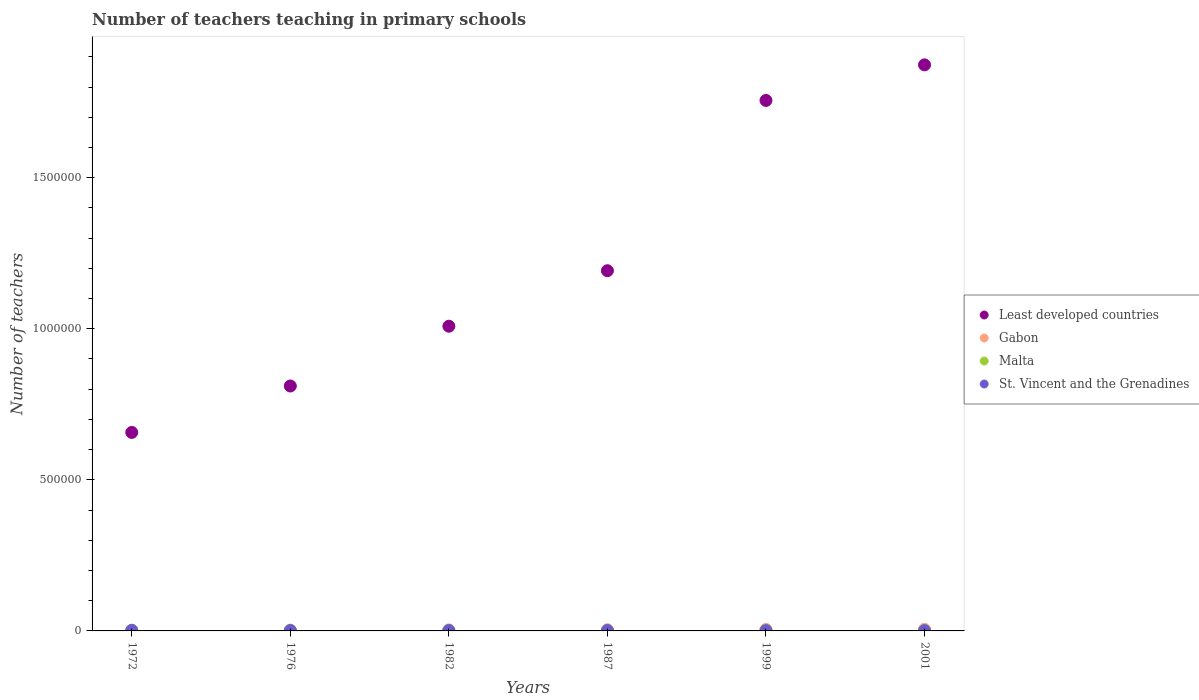How many different coloured dotlines are there?
Provide a short and direct response. 4. Is the number of dotlines equal to the number of legend labels?
Your answer should be very brief. Yes. What is the number of teachers teaching in primary schools in Least developed countries in 2001?
Ensure brevity in your answer.  1.87e+06. Across all years, what is the maximum number of teachers teaching in primary schools in Gabon?
Offer a terse response. 5399. Across all years, what is the minimum number of teachers teaching in primary schools in St. Vincent and the Grenadines?
Provide a succinct answer. 1004. In which year was the number of teachers teaching in primary schools in Malta maximum?
Offer a terse response. 1999. What is the total number of teachers teaching in primary schools in Gabon in the graph?
Give a very brief answer. 2.32e+04. What is the difference between the number of teachers teaching in primary schools in Gabon in 1976 and that in 1999?
Give a very brief answer. -2443. What is the difference between the number of teachers teaching in primary schools in St. Vincent and the Grenadines in 1999 and the number of teachers teaching in primary schools in Least developed countries in 2001?
Make the answer very short. -1.87e+06. What is the average number of teachers teaching in primary schools in Least developed countries per year?
Ensure brevity in your answer.  1.22e+06. In the year 1982, what is the difference between the number of teachers teaching in primary schools in Least developed countries and number of teachers teaching in primary schools in Gabon?
Provide a short and direct response. 1.00e+06. In how many years, is the number of teachers teaching in primary schools in Least developed countries greater than 500000?
Your answer should be compact. 6. What is the ratio of the number of teachers teaching in primary schools in Gabon in 1982 to that in 1999?
Your response must be concise. 0.69. What is the difference between the highest and the second highest number of teachers teaching in primary schools in St. Vincent and the Grenadines?
Give a very brief answer. 507. What is the difference between the highest and the lowest number of teachers teaching in primary schools in Least developed countries?
Keep it short and to the point. 1.22e+06. Is it the case that in every year, the sum of the number of teachers teaching in primary schools in Gabon and number of teachers teaching in primary schools in Malta  is greater than the number of teachers teaching in primary schools in Least developed countries?
Ensure brevity in your answer.  No. Is the number of teachers teaching in primary schools in St. Vincent and the Grenadines strictly greater than the number of teachers teaching in primary schools in Malta over the years?
Your response must be concise. No. What is the difference between two consecutive major ticks on the Y-axis?
Your response must be concise. 5.00e+05. Are the values on the major ticks of Y-axis written in scientific E-notation?
Give a very brief answer. No. Does the graph contain grids?
Ensure brevity in your answer.  No. Where does the legend appear in the graph?
Ensure brevity in your answer.  Center right. How are the legend labels stacked?
Your answer should be compact. Vertical. What is the title of the graph?
Offer a terse response. Number of teachers teaching in primary schools. What is the label or title of the Y-axis?
Keep it short and to the point. Number of teachers. What is the Number of teachers of Least developed countries in 1972?
Ensure brevity in your answer.  6.57e+05. What is the Number of teachers of Gabon in 1972?
Ensure brevity in your answer.  2414. What is the Number of teachers in Malta in 1972?
Provide a short and direct response. 1492. What is the Number of teachers in St. Vincent and the Grenadines in 1972?
Ensure brevity in your answer.  1765. What is the Number of teachers of Least developed countries in 1976?
Provide a succinct answer. 8.11e+05. What is the Number of teachers in Gabon in 1976?
Keep it short and to the point. 2664. What is the Number of teachers in Malta in 1976?
Your answer should be very brief. 1421. What is the Number of teachers of St. Vincent and the Grenadines in 1976?
Your answer should be very brief. 1210. What is the Number of teachers in Least developed countries in 1982?
Offer a terse response. 1.01e+06. What is the Number of teachers in Gabon in 1982?
Give a very brief answer. 3526. What is the Number of teachers of Malta in 1982?
Make the answer very short. 1588. What is the Number of teachers of St. Vincent and the Grenadines in 1982?
Provide a short and direct response. 1184. What is the Number of teachers of Least developed countries in 1987?
Ensure brevity in your answer.  1.19e+06. What is the Number of teachers in Gabon in 1987?
Offer a very short reply. 4083. What is the Number of teachers of Malta in 1987?
Make the answer very short. 1521. What is the Number of teachers of St. Vincent and the Grenadines in 1987?
Your answer should be compact. 1258. What is the Number of teachers in Least developed countries in 1999?
Offer a terse response. 1.76e+06. What is the Number of teachers of Gabon in 1999?
Give a very brief answer. 5107. What is the Number of teachers of Malta in 1999?
Provide a succinct answer. 1779. What is the Number of teachers of St. Vincent and the Grenadines in 1999?
Your answer should be compact. 1004. What is the Number of teachers of Least developed countries in 2001?
Your response must be concise. 1.87e+06. What is the Number of teachers in Gabon in 2001?
Ensure brevity in your answer.  5399. What is the Number of teachers of Malta in 2001?
Give a very brief answer. 1765. What is the Number of teachers of St. Vincent and the Grenadines in 2001?
Provide a succinct answer. 1004. Across all years, what is the maximum Number of teachers in Least developed countries?
Your answer should be compact. 1.87e+06. Across all years, what is the maximum Number of teachers in Gabon?
Provide a short and direct response. 5399. Across all years, what is the maximum Number of teachers in Malta?
Your response must be concise. 1779. Across all years, what is the maximum Number of teachers in St. Vincent and the Grenadines?
Provide a short and direct response. 1765. Across all years, what is the minimum Number of teachers of Least developed countries?
Keep it short and to the point. 6.57e+05. Across all years, what is the minimum Number of teachers of Gabon?
Offer a terse response. 2414. Across all years, what is the minimum Number of teachers in Malta?
Your answer should be compact. 1421. Across all years, what is the minimum Number of teachers in St. Vincent and the Grenadines?
Offer a very short reply. 1004. What is the total Number of teachers of Least developed countries in the graph?
Provide a short and direct response. 7.30e+06. What is the total Number of teachers of Gabon in the graph?
Your answer should be compact. 2.32e+04. What is the total Number of teachers of Malta in the graph?
Keep it short and to the point. 9566. What is the total Number of teachers of St. Vincent and the Grenadines in the graph?
Give a very brief answer. 7425. What is the difference between the Number of teachers of Least developed countries in 1972 and that in 1976?
Keep it short and to the point. -1.54e+05. What is the difference between the Number of teachers in Gabon in 1972 and that in 1976?
Provide a succinct answer. -250. What is the difference between the Number of teachers in Malta in 1972 and that in 1976?
Keep it short and to the point. 71. What is the difference between the Number of teachers of St. Vincent and the Grenadines in 1972 and that in 1976?
Offer a very short reply. 555. What is the difference between the Number of teachers in Least developed countries in 1972 and that in 1982?
Make the answer very short. -3.51e+05. What is the difference between the Number of teachers of Gabon in 1972 and that in 1982?
Your response must be concise. -1112. What is the difference between the Number of teachers in Malta in 1972 and that in 1982?
Ensure brevity in your answer.  -96. What is the difference between the Number of teachers of St. Vincent and the Grenadines in 1972 and that in 1982?
Your answer should be compact. 581. What is the difference between the Number of teachers in Least developed countries in 1972 and that in 1987?
Your answer should be very brief. -5.35e+05. What is the difference between the Number of teachers of Gabon in 1972 and that in 1987?
Make the answer very short. -1669. What is the difference between the Number of teachers in Malta in 1972 and that in 1987?
Provide a short and direct response. -29. What is the difference between the Number of teachers in St. Vincent and the Grenadines in 1972 and that in 1987?
Your answer should be compact. 507. What is the difference between the Number of teachers in Least developed countries in 1972 and that in 1999?
Your answer should be compact. -1.10e+06. What is the difference between the Number of teachers in Gabon in 1972 and that in 1999?
Keep it short and to the point. -2693. What is the difference between the Number of teachers in Malta in 1972 and that in 1999?
Your answer should be compact. -287. What is the difference between the Number of teachers of St. Vincent and the Grenadines in 1972 and that in 1999?
Your answer should be compact. 761. What is the difference between the Number of teachers in Least developed countries in 1972 and that in 2001?
Provide a short and direct response. -1.22e+06. What is the difference between the Number of teachers of Gabon in 1972 and that in 2001?
Ensure brevity in your answer.  -2985. What is the difference between the Number of teachers in Malta in 1972 and that in 2001?
Provide a succinct answer. -273. What is the difference between the Number of teachers in St. Vincent and the Grenadines in 1972 and that in 2001?
Give a very brief answer. 761. What is the difference between the Number of teachers of Least developed countries in 1976 and that in 1982?
Ensure brevity in your answer.  -1.98e+05. What is the difference between the Number of teachers in Gabon in 1976 and that in 1982?
Give a very brief answer. -862. What is the difference between the Number of teachers in Malta in 1976 and that in 1982?
Your answer should be compact. -167. What is the difference between the Number of teachers in St. Vincent and the Grenadines in 1976 and that in 1982?
Ensure brevity in your answer.  26. What is the difference between the Number of teachers of Least developed countries in 1976 and that in 1987?
Keep it short and to the point. -3.81e+05. What is the difference between the Number of teachers in Gabon in 1976 and that in 1987?
Your answer should be very brief. -1419. What is the difference between the Number of teachers in Malta in 1976 and that in 1987?
Ensure brevity in your answer.  -100. What is the difference between the Number of teachers in St. Vincent and the Grenadines in 1976 and that in 1987?
Give a very brief answer. -48. What is the difference between the Number of teachers in Least developed countries in 1976 and that in 1999?
Your answer should be compact. -9.45e+05. What is the difference between the Number of teachers of Gabon in 1976 and that in 1999?
Your answer should be compact. -2443. What is the difference between the Number of teachers in Malta in 1976 and that in 1999?
Ensure brevity in your answer.  -358. What is the difference between the Number of teachers in St. Vincent and the Grenadines in 1976 and that in 1999?
Provide a short and direct response. 206. What is the difference between the Number of teachers of Least developed countries in 1976 and that in 2001?
Make the answer very short. -1.06e+06. What is the difference between the Number of teachers of Gabon in 1976 and that in 2001?
Provide a short and direct response. -2735. What is the difference between the Number of teachers of Malta in 1976 and that in 2001?
Your answer should be compact. -344. What is the difference between the Number of teachers of St. Vincent and the Grenadines in 1976 and that in 2001?
Keep it short and to the point. 206. What is the difference between the Number of teachers in Least developed countries in 1982 and that in 1987?
Offer a very short reply. -1.84e+05. What is the difference between the Number of teachers of Gabon in 1982 and that in 1987?
Provide a short and direct response. -557. What is the difference between the Number of teachers in Malta in 1982 and that in 1987?
Ensure brevity in your answer.  67. What is the difference between the Number of teachers in St. Vincent and the Grenadines in 1982 and that in 1987?
Offer a very short reply. -74. What is the difference between the Number of teachers of Least developed countries in 1982 and that in 1999?
Offer a very short reply. -7.47e+05. What is the difference between the Number of teachers of Gabon in 1982 and that in 1999?
Offer a terse response. -1581. What is the difference between the Number of teachers of Malta in 1982 and that in 1999?
Offer a terse response. -191. What is the difference between the Number of teachers of St. Vincent and the Grenadines in 1982 and that in 1999?
Keep it short and to the point. 180. What is the difference between the Number of teachers of Least developed countries in 1982 and that in 2001?
Give a very brief answer. -8.65e+05. What is the difference between the Number of teachers in Gabon in 1982 and that in 2001?
Ensure brevity in your answer.  -1873. What is the difference between the Number of teachers in Malta in 1982 and that in 2001?
Your answer should be very brief. -177. What is the difference between the Number of teachers of St. Vincent and the Grenadines in 1982 and that in 2001?
Provide a succinct answer. 180. What is the difference between the Number of teachers of Least developed countries in 1987 and that in 1999?
Give a very brief answer. -5.64e+05. What is the difference between the Number of teachers in Gabon in 1987 and that in 1999?
Offer a very short reply. -1024. What is the difference between the Number of teachers of Malta in 1987 and that in 1999?
Your response must be concise. -258. What is the difference between the Number of teachers of St. Vincent and the Grenadines in 1987 and that in 1999?
Offer a very short reply. 254. What is the difference between the Number of teachers of Least developed countries in 1987 and that in 2001?
Give a very brief answer. -6.81e+05. What is the difference between the Number of teachers of Gabon in 1987 and that in 2001?
Your response must be concise. -1316. What is the difference between the Number of teachers of Malta in 1987 and that in 2001?
Provide a succinct answer. -244. What is the difference between the Number of teachers in St. Vincent and the Grenadines in 1987 and that in 2001?
Offer a very short reply. 254. What is the difference between the Number of teachers of Least developed countries in 1999 and that in 2001?
Your answer should be very brief. -1.18e+05. What is the difference between the Number of teachers in Gabon in 1999 and that in 2001?
Make the answer very short. -292. What is the difference between the Number of teachers in St. Vincent and the Grenadines in 1999 and that in 2001?
Keep it short and to the point. 0. What is the difference between the Number of teachers of Least developed countries in 1972 and the Number of teachers of Gabon in 1976?
Give a very brief answer. 6.54e+05. What is the difference between the Number of teachers of Least developed countries in 1972 and the Number of teachers of Malta in 1976?
Your response must be concise. 6.55e+05. What is the difference between the Number of teachers in Least developed countries in 1972 and the Number of teachers in St. Vincent and the Grenadines in 1976?
Keep it short and to the point. 6.56e+05. What is the difference between the Number of teachers in Gabon in 1972 and the Number of teachers in Malta in 1976?
Your response must be concise. 993. What is the difference between the Number of teachers of Gabon in 1972 and the Number of teachers of St. Vincent and the Grenadines in 1976?
Give a very brief answer. 1204. What is the difference between the Number of teachers of Malta in 1972 and the Number of teachers of St. Vincent and the Grenadines in 1976?
Offer a terse response. 282. What is the difference between the Number of teachers of Least developed countries in 1972 and the Number of teachers of Gabon in 1982?
Offer a terse response. 6.53e+05. What is the difference between the Number of teachers in Least developed countries in 1972 and the Number of teachers in Malta in 1982?
Your response must be concise. 6.55e+05. What is the difference between the Number of teachers in Least developed countries in 1972 and the Number of teachers in St. Vincent and the Grenadines in 1982?
Provide a short and direct response. 6.56e+05. What is the difference between the Number of teachers in Gabon in 1972 and the Number of teachers in Malta in 1982?
Make the answer very short. 826. What is the difference between the Number of teachers of Gabon in 1972 and the Number of teachers of St. Vincent and the Grenadines in 1982?
Your answer should be compact. 1230. What is the difference between the Number of teachers of Malta in 1972 and the Number of teachers of St. Vincent and the Grenadines in 1982?
Offer a terse response. 308. What is the difference between the Number of teachers in Least developed countries in 1972 and the Number of teachers in Gabon in 1987?
Provide a succinct answer. 6.53e+05. What is the difference between the Number of teachers in Least developed countries in 1972 and the Number of teachers in Malta in 1987?
Make the answer very short. 6.55e+05. What is the difference between the Number of teachers in Least developed countries in 1972 and the Number of teachers in St. Vincent and the Grenadines in 1987?
Keep it short and to the point. 6.56e+05. What is the difference between the Number of teachers in Gabon in 1972 and the Number of teachers in Malta in 1987?
Offer a terse response. 893. What is the difference between the Number of teachers in Gabon in 1972 and the Number of teachers in St. Vincent and the Grenadines in 1987?
Keep it short and to the point. 1156. What is the difference between the Number of teachers of Malta in 1972 and the Number of teachers of St. Vincent and the Grenadines in 1987?
Your response must be concise. 234. What is the difference between the Number of teachers in Least developed countries in 1972 and the Number of teachers in Gabon in 1999?
Provide a short and direct response. 6.52e+05. What is the difference between the Number of teachers of Least developed countries in 1972 and the Number of teachers of Malta in 1999?
Your answer should be compact. 6.55e+05. What is the difference between the Number of teachers in Least developed countries in 1972 and the Number of teachers in St. Vincent and the Grenadines in 1999?
Give a very brief answer. 6.56e+05. What is the difference between the Number of teachers of Gabon in 1972 and the Number of teachers of Malta in 1999?
Offer a very short reply. 635. What is the difference between the Number of teachers in Gabon in 1972 and the Number of teachers in St. Vincent and the Grenadines in 1999?
Provide a short and direct response. 1410. What is the difference between the Number of teachers in Malta in 1972 and the Number of teachers in St. Vincent and the Grenadines in 1999?
Your answer should be very brief. 488. What is the difference between the Number of teachers of Least developed countries in 1972 and the Number of teachers of Gabon in 2001?
Your response must be concise. 6.51e+05. What is the difference between the Number of teachers in Least developed countries in 1972 and the Number of teachers in Malta in 2001?
Offer a very short reply. 6.55e+05. What is the difference between the Number of teachers in Least developed countries in 1972 and the Number of teachers in St. Vincent and the Grenadines in 2001?
Your response must be concise. 6.56e+05. What is the difference between the Number of teachers in Gabon in 1972 and the Number of teachers in Malta in 2001?
Your answer should be very brief. 649. What is the difference between the Number of teachers in Gabon in 1972 and the Number of teachers in St. Vincent and the Grenadines in 2001?
Provide a succinct answer. 1410. What is the difference between the Number of teachers in Malta in 1972 and the Number of teachers in St. Vincent and the Grenadines in 2001?
Your answer should be compact. 488. What is the difference between the Number of teachers of Least developed countries in 1976 and the Number of teachers of Gabon in 1982?
Your response must be concise. 8.07e+05. What is the difference between the Number of teachers of Least developed countries in 1976 and the Number of teachers of Malta in 1982?
Your response must be concise. 8.09e+05. What is the difference between the Number of teachers in Least developed countries in 1976 and the Number of teachers in St. Vincent and the Grenadines in 1982?
Give a very brief answer. 8.09e+05. What is the difference between the Number of teachers of Gabon in 1976 and the Number of teachers of Malta in 1982?
Provide a succinct answer. 1076. What is the difference between the Number of teachers of Gabon in 1976 and the Number of teachers of St. Vincent and the Grenadines in 1982?
Offer a terse response. 1480. What is the difference between the Number of teachers in Malta in 1976 and the Number of teachers in St. Vincent and the Grenadines in 1982?
Give a very brief answer. 237. What is the difference between the Number of teachers in Least developed countries in 1976 and the Number of teachers in Gabon in 1987?
Your answer should be very brief. 8.06e+05. What is the difference between the Number of teachers in Least developed countries in 1976 and the Number of teachers in Malta in 1987?
Your answer should be very brief. 8.09e+05. What is the difference between the Number of teachers in Least developed countries in 1976 and the Number of teachers in St. Vincent and the Grenadines in 1987?
Provide a short and direct response. 8.09e+05. What is the difference between the Number of teachers of Gabon in 1976 and the Number of teachers of Malta in 1987?
Your response must be concise. 1143. What is the difference between the Number of teachers of Gabon in 1976 and the Number of teachers of St. Vincent and the Grenadines in 1987?
Ensure brevity in your answer.  1406. What is the difference between the Number of teachers of Malta in 1976 and the Number of teachers of St. Vincent and the Grenadines in 1987?
Provide a short and direct response. 163. What is the difference between the Number of teachers in Least developed countries in 1976 and the Number of teachers in Gabon in 1999?
Offer a very short reply. 8.05e+05. What is the difference between the Number of teachers in Least developed countries in 1976 and the Number of teachers in Malta in 1999?
Offer a terse response. 8.09e+05. What is the difference between the Number of teachers in Least developed countries in 1976 and the Number of teachers in St. Vincent and the Grenadines in 1999?
Provide a short and direct response. 8.10e+05. What is the difference between the Number of teachers in Gabon in 1976 and the Number of teachers in Malta in 1999?
Provide a succinct answer. 885. What is the difference between the Number of teachers of Gabon in 1976 and the Number of teachers of St. Vincent and the Grenadines in 1999?
Keep it short and to the point. 1660. What is the difference between the Number of teachers of Malta in 1976 and the Number of teachers of St. Vincent and the Grenadines in 1999?
Offer a very short reply. 417. What is the difference between the Number of teachers in Least developed countries in 1976 and the Number of teachers in Gabon in 2001?
Offer a very short reply. 8.05e+05. What is the difference between the Number of teachers of Least developed countries in 1976 and the Number of teachers of Malta in 2001?
Offer a terse response. 8.09e+05. What is the difference between the Number of teachers in Least developed countries in 1976 and the Number of teachers in St. Vincent and the Grenadines in 2001?
Offer a very short reply. 8.10e+05. What is the difference between the Number of teachers in Gabon in 1976 and the Number of teachers in Malta in 2001?
Offer a terse response. 899. What is the difference between the Number of teachers in Gabon in 1976 and the Number of teachers in St. Vincent and the Grenadines in 2001?
Your response must be concise. 1660. What is the difference between the Number of teachers in Malta in 1976 and the Number of teachers in St. Vincent and the Grenadines in 2001?
Provide a short and direct response. 417. What is the difference between the Number of teachers in Least developed countries in 1982 and the Number of teachers in Gabon in 1987?
Ensure brevity in your answer.  1.00e+06. What is the difference between the Number of teachers in Least developed countries in 1982 and the Number of teachers in Malta in 1987?
Make the answer very short. 1.01e+06. What is the difference between the Number of teachers in Least developed countries in 1982 and the Number of teachers in St. Vincent and the Grenadines in 1987?
Offer a very short reply. 1.01e+06. What is the difference between the Number of teachers in Gabon in 1982 and the Number of teachers in Malta in 1987?
Give a very brief answer. 2005. What is the difference between the Number of teachers in Gabon in 1982 and the Number of teachers in St. Vincent and the Grenadines in 1987?
Your answer should be very brief. 2268. What is the difference between the Number of teachers in Malta in 1982 and the Number of teachers in St. Vincent and the Grenadines in 1987?
Make the answer very short. 330. What is the difference between the Number of teachers of Least developed countries in 1982 and the Number of teachers of Gabon in 1999?
Your answer should be very brief. 1.00e+06. What is the difference between the Number of teachers of Least developed countries in 1982 and the Number of teachers of Malta in 1999?
Offer a very short reply. 1.01e+06. What is the difference between the Number of teachers of Least developed countries in 1982 and the Number of teachers of St. Vincent and the Grenadines in 1999?
Keep it short and to the point. 1.01e+06. What is the difference between the Number of teachers in Gabon in 1982 and the Number of teachers in Malta in 1999?
Offer a terse response. 1747. What is the difference between the Number of teachers of Gabon in 1982 and the Number of teachers of St. Vincent and the Grenadines in 1999?
Your response must be concise. 2522. What is the difference between the Number of teachers in Malta in 1982 and the Number of teachers in St. Vincent and the Grenadines in 1999?
Offer a very short reply. 584. What is the difference between the Number of teachers of Least developed countries in 1982 and the Number of teachers of Gabon in 2001?
Ensure brevity in your answer.  1.00e+06. What is the difference between the Number of teachers of Least developed countries in 1982 and the Number of teachers of Malta in 2001?
Make the answer very short. 1.01e+06. What is the difference between the Number of teachers of Least developed countries in 1982 and the Number of teachers of St. Vincent and the Grenadines in 2001?
Your response must be concise. 1.01e+06. What is the difference between the Number of teachers of Gabon in 1982 and the Number of teachers of Malta in 2001?
Your answer should be very brief. 1761. What is the difference between the Number of teachers of Gabon in 1982 and the Number of teachers of St. Vincent and the Grenadines in 2001?
Offer a very short reply. 2522. What is the difference between the Number of teachers in Malta in 1982 and the Number of teachers in St. Vincent and the Grenadines in 2001?
Offer a terse response. 584. What is the difference between the Number of teachers of Least developed countries in 1987 and the Number of teachers of Gabon in 1999?
Ensure brevity in your answer.  1.19e+06. What is the difference between the Number of teachers in Least developed countries in 1987 and the Number of teachers in Malta in 1999?
Your response must be concise. 1.19e+06. What is the difference between the Number of teachers in Least developed countries in 1987 and the Number of teachers in St. Vincent and the Grenadines in 1999?
Your answer should be very brief. 1.19e+06. What is the difference between the Number of teachers in Gabon in 1987 and the Number of teachers in Malta in 1999?
Provide a short and direct response. 2304. What is the difference between the Number of teachers of Gabon in 1987 and the Number of teachers of St. Vincent and the Grenadines in 1999?
Give a very brief answer. 3079. What is the difference between the Number of teachers in Malta in 1987 and the Number of teachers in St. Vincent and the Grenadines in 1999?
Give a very brief answer. 517. What is the difference between the Number of teachers of Least developed countries in 1987 and the Number of teachers of Gabon in 2001?
Make the answer very short. 1.19e+06. What is the difference between the Number of teachers in Least developed countries in 1987 and the Number of teachers in Malta in 2001?
Your response must be concise. 1.19e+06. What is the difference between the Number of teachers of Least developed countries in 1987 and the Number of teachers of St. Vincent and the Grenadines in 2001?
Ensure brevity in your answer.  1.19e+06. What is the difference between the Number of teachers in Gabon in 1987 and the Number of teachers in Malta in 2001?
Keep it short and to the point. 2318. What is the difference between the Number of teachers in Gabon in 1987 and the Number of teachers in St. Vincent and the Grenadines in 2001?
Your answer should be compact. 3079. What is the difference between the Number of teachers in Malta in 1987 and the Number of teachers in St. Vincent and the Grenadines in 2001?
Give a very brief answer. 517. What is the difference between the Number of teachers in Least developed countries in 1999 and the Number of teachers in Gabon in 2001?
Your response must be concise. 1.75e+06. What is the difference between the Number of teachers of Least developed countries in 1999 and the Number of teachers of Malta in 2001?
Offer a terse response. 1.75e+06. What is the difference between the Number of teachers of Least developed countries in 1999 and the Number of teachers of St. Vincent and the Grenadines in 2001?
Provide a short and direct response. 1.75e+06. What is the difference between the Number of teachers in Gabon in 1999 and the Number of teachers in Malta in 2001?
Provide a succinct answer. 3342. What is the difference between the Number of teachers of Gabon in 1999 and the Number of teachers of St. Vincent and the Grenadines in 2001?
Your response must be concise. 4103. What is the difference between the Number of teachers in Malta in 1999 and the Number of teachers in St. Vincent and the Grenadines in 2001?
Ensure brevity in your answer.  775. What is the average Number of teachers in Least developed countries per year?
Offer a terse response. 1.22e+06. What is the average Number of teachers in Gabon per year?
Offer a very short reply. 3865.5. What is the average Number of teachers of Malta per year?
Make the answer very short. 1594.33. What is the average Number of teachers in St. Vincent and the Grenadines per year?
Ensure brevity in your answer.  1237.5. In the year 1972, what is the difference between the Number of teachers in Least developed countries and Number of teachers in Gabon?
Give a very brief answer. 6.54e+05. In the year 1972, what is the difference between the Number of teachers of Least developed countries and Number of teachers of Malta?
Offer a terse response. 6.55e+05. In the year 1972, what is the difference between the Number of teachers in Least developed countries and Number of teachers in St. Vincent and the Grenadines?
Offer a very short reply. 6.55e+05. In the year 1972, what is the difference between the Number of teachers of Gabon and Number of teachers of Malta?
Provide a short and direct response. 922. In the year 1972, what is the difference between the Number of teachers in Gabon and Number of teachers in St. Vincent and the Grenadines?
Your answer should be very brief. 649. In the year 1972, what is the difference between the Number of teachers of Malta and Number of teachers of St. Vincent and the Grenadines?
Provide a short and direct response. -273. In the year 1976, what is the difference between the Number of teachers in Least developed countries and Number of teachers in Gabon?
Your answer should be very brief. 8.08e+05. In the year 1976, what is the difference between the Number of teachers of Least developed countries and Number of teachers of Malta?
Ensure brevity in your answer.  8.09e+05. In the year 1976, what is the difference between the Number of teachers of Least developed countries and Number of teachers of St. Vincent and the Grenadines?
Your answer should be compact. 8.09e+05. In the year 1976, what is the difference between the Number of teachers in Gabon and Number of teachers in Malta?
Give a very brief answer. 1243. In the year 1976, what is the difference between the Number of teachers in Gabon and Number of teachers in St. Vincent and the Grenadines?
Give a very brief answer. 1454. In the year 1976, what is the difference between the Number of teachers in Malta and Number of teachers in St. Vincent and the Grenadines?
Your answer should be very brief. 211. In the year 1982, what is the difference between the Number of teachers of Least developed countries and Number of teachers of Gabon?
Ensure brevity in your answer.  1.00e+06. In the year 1982, what is the difference between the Number of teachers of Least developed countries and Number of teachers of Malta?
Offer a terse response. 1.01e+06. In the year 1982, what is the difference between the Number of teachers of Least developed countries and Number of teachers of St. Vincent and the Grenadines?
Keep it short and to the point. 1.01e+06. In the year 1982, what is the difference between the Number of teachers of Gabon and Number of teachers of Malta?
Provide a succinct answer. 1938. In the year 1982, what is the difference between the Number of teachers of Gabon and Number of teachers of St. Vincent and the Grenadines?
Keep it short and to the point. 2342. In the year 1982, what is the difference between the Number of teachers of Malta and Number of teachers of St. Vincent and the Grenadines?
Keep it short and to the point. 404. In the year 1987, what is the difference between the Number of teachers of Least developed countries and Number of teachers of Gabon?
Your answer should be compact. 1.19e+06. In the year 1987, what is the difference between the Number of teachers in Least developed countries and Number of teachers in Malta?
Make the answer very short. 1.19e+06. In the year 1987, what is the difference between the Number of teachers in Least developed countries and Number of teachers in St. Vincent and the Grenadines?
Offer a terse response. 1.19e+06. In the year 1987, what is the difference between the Number of teachers in Gabon and Number of teachers in Malta?
Ensure brevity in your answer.  2562. In the year 1987, what is the difference between the Number of teachers in Gabon and Number of teachers in St. Vincent and the Grenadines?
Offer a terse response. 2825. In the year 1987, what is the difference between the Number of teachers in Malta and Number of teachers in St. Vincent and the Grenadines?
Ensure brevity in your answer.  263. In the year 1999, what is the difference between the Number of teachers of Least developed countries and Number of teachers of Gabon?
Provide a short and direct response. 1.75e+06. In the year 1999, what is the difference between the Number of teachers of Least developed countries and Number of teachers of Malta?
Make the answer very short. 1.75e+06. In the year 1999, what is the difference between the Number of teachers in Least developed countries and Number of teachers in St. Vincent and the Grenadines?
Ensure brevity in your answer.  1.75e+06. In the year 1999, what is the difference between the Number of teachers of Gabon and Number of teachers of Malta?
Keep it short and to the point. 3328. In the year 1999, what is the difference between the Number of teachers of Gabon and Number of teachers of St. Vincent and the Grenadines?
Offer a terse response. 4103. In the year 1999, what is the difference between the Number of teachers in Malta and Number of teachers in St. Vincent and the Grenadines?
Offer a very short reply. 775. In the year 2001, what is the difference between the Number of teachers in Least developed countries and Number of teachers in Gabon?
Offer a very short reply. 1.87e+06. In the year 2001, what is the difference between the Number of teachers of Least developed countries and Number of teachers of Malta?
Provide a short and direct response. 1.87e+06. In the year 2001, what is the difference between the Number of teachers of Least developed countries and Number of teachers of St. Vincent and the Grenadines?
Your response must be concise. 1.87e+06. In the year 2001, what is the difference between the Number of teachers of Gabon and Number of teachers of Malta?
Keep it short and to the point. 3634. In the year 2001, what is the difference between the Number of teachers of Gabon and Number of teachers of St. Vincent and the Grenadines?
Your answer should be very brief. 4395. In the year 2001, what is the difference between the Number of teachers of Malta and Number of teachers of St. Vincent and the Grenadines?
Offer a terse response. 761. What is the ratio of the Number of teachers of Least developed countries in 1972 to that in 1976?
Give a very brief answer. 0.81. What is the ratio of the Number of teachers of Gabon in 1972 to that in 1976?
Offer a very short reply. 0.91. What is the ratio of the Number of teachers of St. Vincent and the Grenadines in 1972 to that in 1976?
Your answer should be compact. 1.46. What is the ratio of the Number of teachers of Least developed countries in 1972 to that in 1982?
Ensure brevity in your answer.  0.65. What is the ratio of the Number of teachers of Gabon in 1972 to that in 1982?
Provide a succinct answer. 0.68. What is the ratio of the Number of teachers in Malta in 1972 to that in 1982?
Ensure brevity in your answer.  0.94. What is the ratio of the Number of teachers of St. Vincent and the Grenadines in 1972 to that in 1982?
Keep it short and to the point. 1.49. What is the ratio of the Number of teachers in Least developed countries in 1972 to that in 1987?
Give a very brief answer. 0.55. What is the ratio of the Number of teachers in Gabon in 1972 to that in 1987?
Make the answer very short. 0.59. What is the ratio of the Number of teachers of Malta in 1972 to that in 1987?
Offer a very short reply. 0.98. What is the ratio of the Number of teachers of St. Vincent and the Grenadines in 1972 to that in 1987?
Keep it short and to the point. 1.4. What is the ratio of the Number of teachers in Least developed countries in 1972 to that in 1999?
Your answer should be compact. 0.37. What is the ratio of the Number of teachers in Gabon in 1972 to that in 1999?
Offer a very short reply. 0.47. What is the ratio of the Number of teachers of Malta in 1972 to that in 1999?
Offer a very short reply. 0.84. What is the ratio of the Number of teachers in St. Vincent and the Grenadines in 1972 to that in 1999?
Ensure brevity in your answer.  1.76. What is the ratio of the Number of teachers in Least developed countries in 1972 to that in 2001?
Provide a short and direct response. 0.35. What is the ratio of the Number of teachers of Gabon in 1972 to that in 2001?
Your answer should be compact. 0.45. What is the ratio of the Number of teachers of Malta in 1972 to that in 2001?
Give a very brief answer. 0.85. What is the ratio of the Number of teachers of St. Vincent and the Grenadines in 1972 to that in 2001?
Provide a succinct answer. 1.76. What is the ratio of the Number of teachers of Least developed countries in 1976 to that in 1982?
Your answer should be very brief. 0.8. What is the ratio of the Number of teachers of Gabon in 1976 to that in 1982?
Ensure brevity in your answer.  0.76. What is the ratio of the Number of teachers of Malta in 1976 to that in 1982?
Provide a short and direct response. 0.89. What is the ratio of the Number of teachers of Least developed countries in 1976 to that in 1987?
Your answer should be compact. 0.68. What is the ratio of the Number of teachers in Gabon in 1976 to that in 1987?
Give a very brief answer. 0.65. What is the ratio of the Number of teachers in Malta in 1976 to that in 1987?
Your answer should be compact. 0.93. What is the ratio of the Number of teachers of St. Vincent and the Grenadines in 1976 to that in 1987?
Your answer should be compact. 0.96. What is the ratio of the Number of teachers in Least developed countries in 1976 to that in 1999?
Give a very brief answer. 0.46. What is the ratio of the Number of teachers in Gabon in 1976 to that in 1999?
Provide a succinct answer. 0.52. What is the ratio of the Number of teachers in Malta in 1976 to that in 1999?
Your response must be concise. 0.8. What is the ratio of the Number of teachers in St. Vincent and the Grenadines in 1976 to that in 1999?
Your response must be concise. 1.21. What is the ratio of the Number of teachers in Least developed countries in 1976 to that in 2001?
Offer a terse response. 0.43. What is the ratio of the Number of teachers in Gabon in 1976 to that in 2001?
Make the answer very short. 0.49. What is the ratio of the Number of teachers in Malta in 1976 to that in 2001?
Provide a short and direct response. 0.81. What is the ratio of the Number of teachers in St. Vincent and the Grenadines in 1976 to that in 2001?
Keep it short and to the point. 1.21. What is the ratio of the Number of teachers of Least developed countries in 1982 to that in 1987?
Your response must be concise. 0.85. What is the ratio of the Number of teachers in Gabon in 1982 to that in 1987?
Your response must be concise. 0.86. What is the ratio of the Number of teachers in Malta in 1982 to that in 1987?
Your answer should be very brief. 1.04. What is the ratio of the Number of teachers in Least developed countries in 1982 to that in 1999?
Give a very brief answer. 0.57. What is the ratio of the Number of teachers of Gabon in 1982 to that in 1999?
Your answer should be very brief. 0.69. What is the ratio of the Number of teachers of Malta in 1982 to that in 1999?
Your answer should be very brief. 0.89. What is the ratio of the Number of teachers in St. Vincent and the Grenadines in 1982 to that in 1999?
Keep it short and to the point. 1.18. What is the ratio of the Number of teachers of Least developed countries in 1982 to that in 2001?
Make the answer very short. 0.54. What is the ratio of the Number of teachers in Gabon in 1982 to that in 2001?
Offer a very short reply. 0.65. What is the ratio of the Number of teachers in Malta in 1982 to that in 2001?
Offer a terse response. 0.9. What is the ratio of the Number of teachers of St. Vincent and the Grenadines in 1982 to that in 2001?
Your response must be concise. 1.18. What is the ratio of the Number of teachers of Least developed countries in 1987 to that in 1999?
Ensure brevity in your answer.  0.68. What is the ratio of the Number of teachers in Gabon in 1987 to that in 1999?
Provide a succinct answer. 0.8. What is the ratio of the Number of teachers of Malta in 1987 to that in 1999?
Keep it short and to the point. 0.85. What is the ratio of the Number of teachers in St. Vincent and the Grenadines in 1987 to that in 1999?
Your answer should be compact. 1.25. What is the ratio of the Number of teachers of Least developed countries in 1987 to that in 2001?
Keep it short and to the point. 0.64. What is the ratio of the Number of teachers in Gabon in 1987 to that in 2001?
Your answer should be very brief. 0.76. What is the ratio of the Number of teachers in Malta in 1987 to that in 2001?
Your answer should be very brief. 0.86. What is the ratio of the Number of teachers in St. Vincent and the Grenadines in 1987 to that in 2001?
Your answer should be compact. 1.25. What is the ratio of the Number of teachers of Least developed countries in 1999 to that in 2001?
Your answer should be very brief. 0.94. What is the ratio of the Number of teachers in Gabon in 1999 to that in 2001?
Provide a succinct answer. 0.95. What is the ratio of the Number of teachers of Malta in 1999 to that in 2001?
Your answer should be compact. 1.01. What is the ratio of the Number of teachers in St. Vincent and the Grenadines in 1999 to that in 2001?
Offer a terse response. 1. What is the difference between the highest and the second highest Number of teachers in Least developed countries?
Provide a short and direct response. 1.18e+05. What is the difference between the highest and the second highest Number of teachers of Gabon?
Make the answer very short. 292. What is the difference between the highest and the second highest Number of teachers in Malta?
Give a very brief answer. 14. What is the difference between the highest and the second highest Number of teachers in St. Vincent and the Grenadines?
Provide a short and direct response. 507. What is the difference between the highest and the lowest Number of teachers of Least developed countries?
Your response must be concise. 1.22e+06. What is the difference between the highest and the lowest Number of teachers in Gabon?
Offer a terse response. 2985. What is the difference between the highest and the lowest Number of teachers in Malta?
Make the answer very short. 358. What is the difference between the highest and the lowest Number of teachers in St. Vincent and the Grenadines?
Keep it short and to the point. 761. 